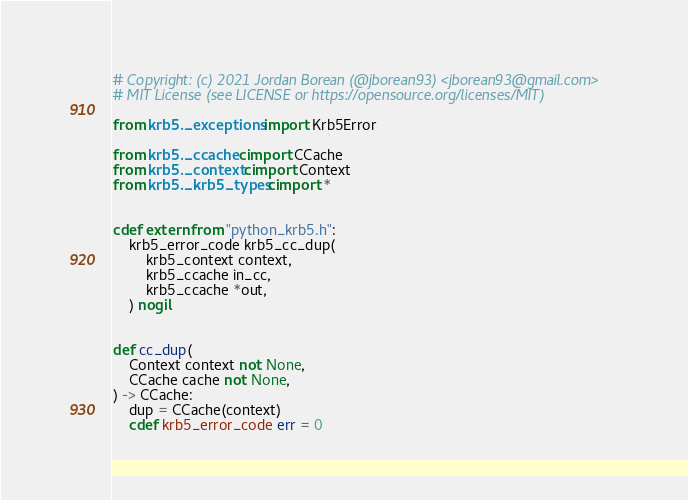<code> <loc_0><loc_0><loc_500><loc_500><_Cython_># Copyright: (c) 2021 Jordan Borean (@jborean93) <jborean93@gmail.com>
# MIT License (see LICENSE or https://opensource.org/licenses/MIT)

from krb5._exceptions import Krb5Error

from krb5._ccache cimport CCache
from krb5._context cimport Context
from krb5._krb5_types cimport *


cdef extern from "python_krb5.h":
    krb5_error_code krb5_cc_dup(
        krb5_context context,
        krb5_ccache in_cc,
        krb5_ccache *out,
    ) nogil


def cc_dup(
    Context context not None,
    CCache cache not None,
) -> CCache:
    dup = CCache(context)
    cdef krb5_error_code err = 0
</code> 